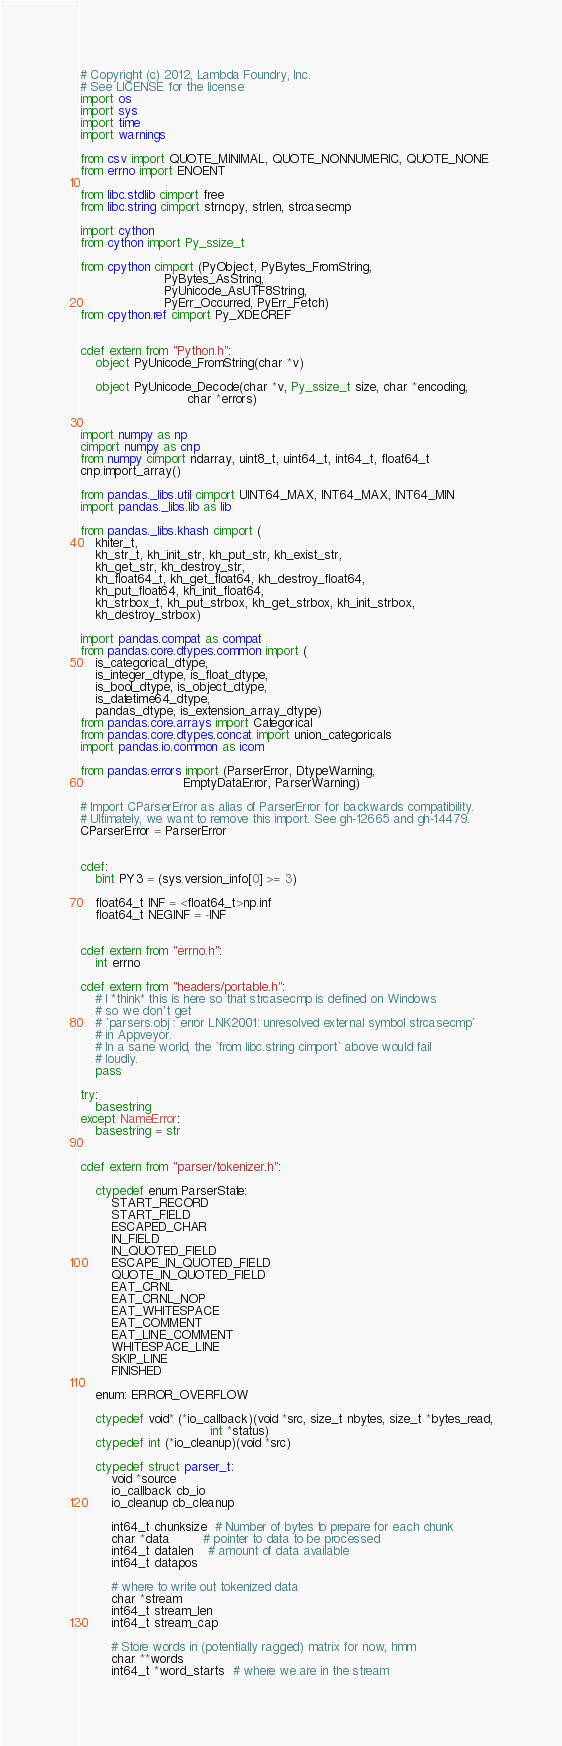<code> <loc_0><loc_0><loc_500><loc_500><_Cython_># Copyright (c) 2012, Lambda Foundry, Inc.
# See LICENSE for the license
import os
import sys
import time
import warnings

from csv import QUOTE_MINIMAL, QUOTE_NONNUMERIC, QUOTE_NONE
from errno import ENOENT

from libc.stdlib cimport free
from libc.string cimport strncpy, strlen, strcasecmp

import cython
from cython import Py_ssize_t

from cpython cimport (PyObject, PyBytes_FromString,
                      PyBytes_AsString,
                      PyUnicode_AsUTF8String,
                      PyErr_Occurred, PyErr_Fetch)
from cpython.ref cimport Py_XDECREF


cdef extern from "Python.h":
    object PyUnicode_FromString(char *v)

    object PyUnicode_Decode(char *v, Py_ssize_t size, char *encoding,
                            char *errors)


import numpy as np
cimport numpy as cnp
from numpy cimport ndarray, uint8_t, uint64_t, int64_t, float64_t
cnp.import_array()

from pandas._libs.util cimport UINT64_MAX, INT64_MAX, INT64_MIN
import pandas._libs.lib as lib

from pandas._libs.khash cimport (
    khiter_t,
    kh_str_t, kh_init_str, kh_put_str, kh_exist_str,
    kh_get_str, kh_destroy_str,
    kh_float64_t, kh_get_float64, kh_destroy_float64,
    kh_put_float64, kh_init_float64,
    kh_strbox_t, kh_put_strbox, kh_get_strbox, kh_init_strbox,
    kh_destroy_strbox)

import pandas.compat as compat
from pandas.core.dtypes.common import (
    is_categorical_dtype,
    is_integer_dtype, is_float_dtype,
    is_bool_dtype, is_object_dtype,
    is_datetime64_dtype,
    pandas_dtype, is_extension_array_dtype)
from pandas.core.arrays import Categorical
from pandas.core.dtypes.concat import union_categoricals
import pandas.io.common as icom

from pandas.errors import (ParserError, DtypeWarning,
                           EmptyDataError, ParserWarning)

# Import CParserError as alias of ParserError for backwards compatibility.
# Ultimately, we want to remove this import. See gh-12665 and gh-14479.
CParserError = ParserError


cdef:
    bint PY3 = (sys.version_info[0] >= 3)

    float64_t INF = <float64_t>np.inf
    float64_t NEGINF = -INF


cdef extern from "errno.h":
    int errno

cdef extern from "headers/portable.h":
    # I *think* this is here so that strcasecmp is defined on Windows
    # so we don't get
    # `parsers.obj : error LNK2001: unresolved external symbol strcasecmp`
    # in Appveyor.
    # In a sane world, the `from libc.string cimport` above would fail
    # loudly.
    pass

try:
    basestring
except NameError:
    basestring = str


cdef extern from "parser/tokenizer.h":

    ctypedef enum ParserState:
        START_RECORD
        START_FIELD
        ESCAPED_CHAR
        IN_FIELD
        IN_QUOTED_FIELD
        ESCAPE_IN_QUOTED_FIELD
        QUOTE_IN_QUOTED_FIELD
        EAT_CRNL
        EAT_CRNL_NOP
        EAT_WHITESPACE
        EAT_COMMENT
        EAT_LINE_COMMENT
        WHITESPACE_LINE
        SKIP_LINE
        FINISHED

    enum: ERROR_OVERFLOW

    ctypedef void* (*io_callback)(void *src, size_t nbytes, size_t *bytes_read,
                                  int *status)
    ctypedef int (*io_cleanup)(void *src)

    ctypedef struct parser_t:
        void *source
        io_callback cb_io
        io_cleanup cb_cleanup

        int64_t chunksize  # Number of bytes to prepare for each chunk
        char *data         # pointer to data to be processed
        int64_t datalen    # amount of data available
        int64_t datapos

        # where to write out tokenized data
        char *stream
        int64_t stream_len
        int64_t stream_cap

        # Store words in (potentially ragged) matrix for now, hmm
        char **words
        int64_t *word_starts  # where we are in the stream</code> 